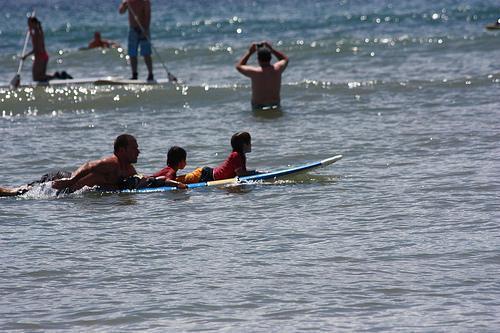How many kids on the surfing board?
Give a very brief answer. 2. 